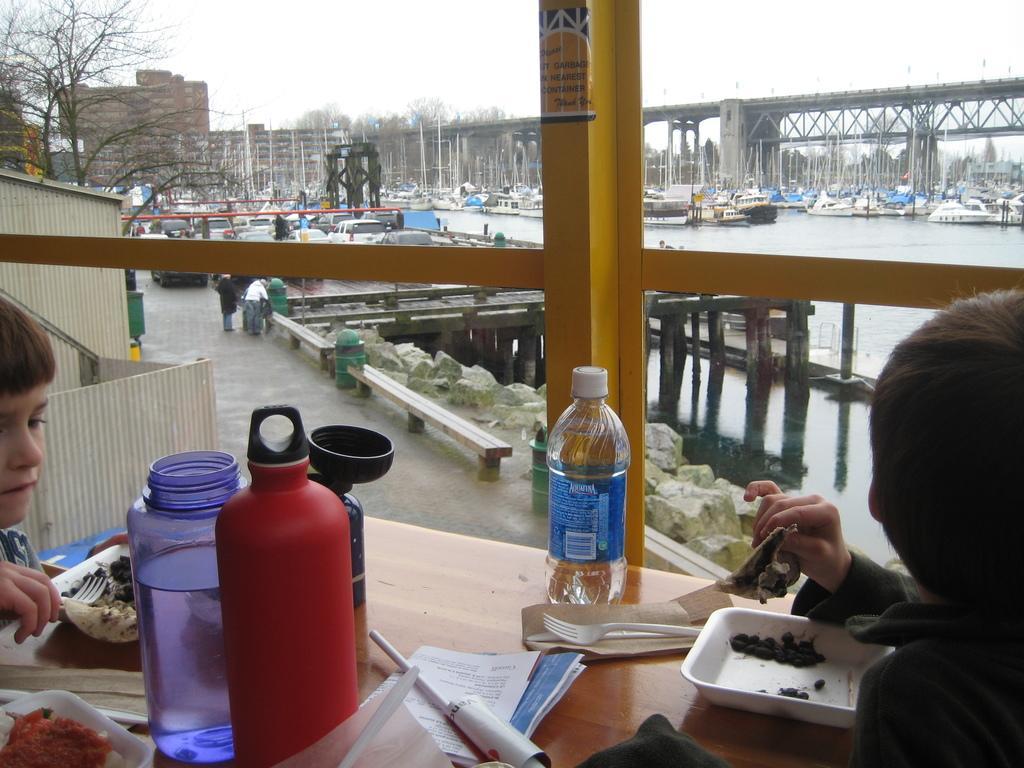Can you describe this image briefly? This picture shows a bridge and couple of buildings and trees and we see people standing and we see a ocean and few ships and boats and we see a water bottle and some food and a fork and some papers on the table and two men seated 